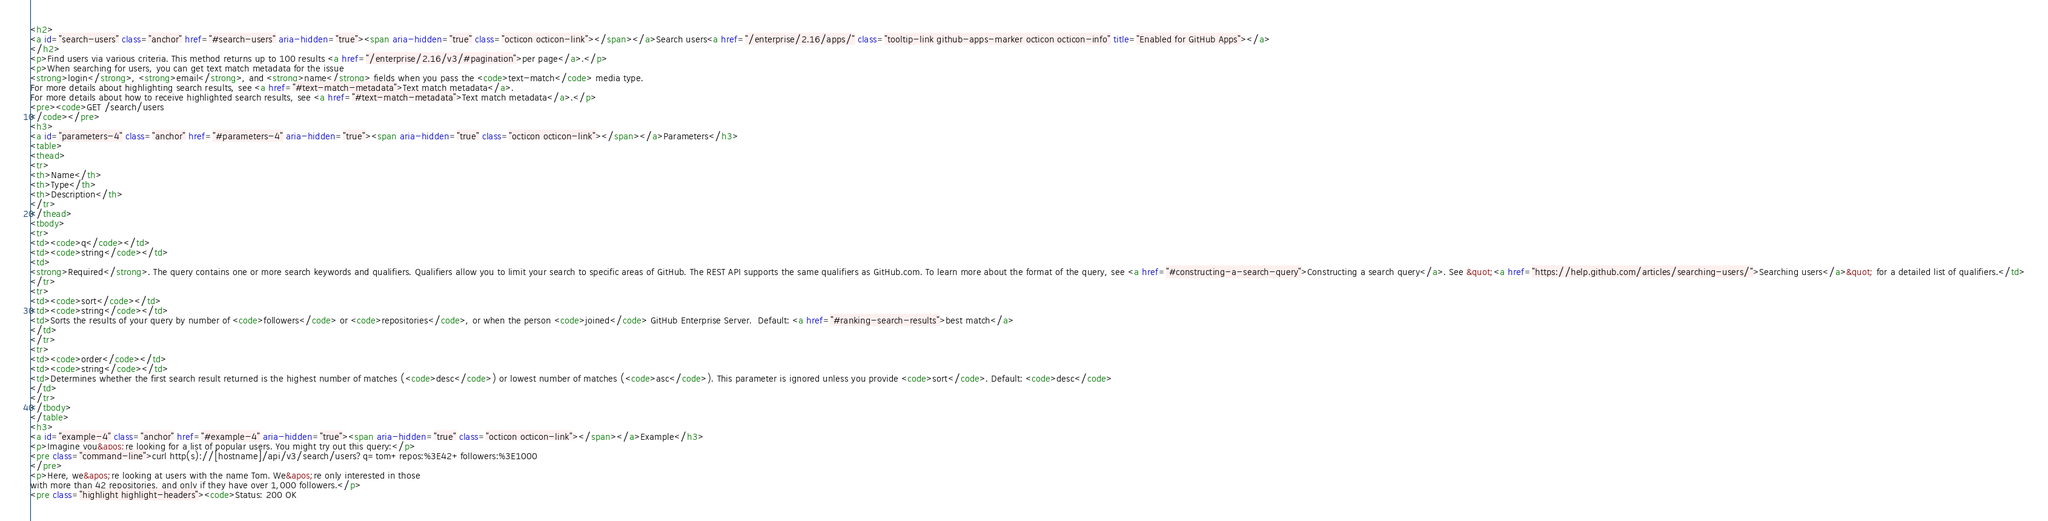Convert code to text. <code><loc_0><loc_0><loc_500><loc_500><_HTML_><h2>
<a id="search-users" class="anchor" href="#search-users" aria-hidden="true"><span aria-hidden="true" class="octicon octicon-link"></span></a>Search users<a href="/enterprise/2.16/apps/" class="tooltip-link github-apps-marker octicon octicon-info" title="Enabled for GitHub Apps"></a>
</h2>
<p>Find users via various criteria. This method returns up to 100 results <a href="/enterprise/2.16/v3/#pagination">per page</a>.</p>
<p>When searching for users, you can get text match metadata for the issue
<strong>login</strong>, <strong>email</strong>, and <strong>name</strong> fields when you pass the <code>text-match</code> media type.
For more details about highlighting search results, see <a href="#text-match-metadata">Text match metadata</a>.
For more details about how to receive highlighted search results, see <a href="#text-match-metadata">Text match metadata</a>.</p>
<pre><code>GET /search/users
</code></pre>
<h3>
<a id="parameters-4" class="anchor" href="#parameters-4" aria-hidden="true"><span aria-hidden="true" class="octicon octicon-link"></span></a>Parameters</h3>
<table>
<thead>
<tr>
<th>Name</th>
<th>Type</th>
<th>Description</th>
</tr>
</thead>
<tbody>
<tr>
<td><code>q</code></td>
<td><code>string</code></td>
<td>
<strong>Required</strong>. The query contains one or more search keywords and qualifiers. Qualifiers allow you to limit your search to specific areas of GitHub. The REST API supports the same qualifiers as GitHub.com. To learn more about the format of the query, see <a href="#constructing-a-search-query">Constructing a search query</a>. See &quot;<a href="https://help.github.com/articles/searching-users/">Searching users</a>&quot; for a detailed list of qualifiers.</td>
</tr>
<tr>
<td><code>sort</code></td>
<td><code>string</code></td>
<td>Sorts the results of your query by number of <code>followers</code> or <code>repositories</code>, or when the person <code>joined</code> GitHub Enterprise Server.  Default: <a href="#ranking-search-results">best match</a>
</td>
</tr>
<tr>
<td><code>order</code></td>
<td><code>string</code></td>
<td>Determines whether the first search result returned is the highest number of matches (<code>desc</code>) or lowest number of matches (<code>asc</code>). This parameter is ignored unless you provide <code>sort</code>. Default: <code>desc</code>
</td>
</tr>
</tbody>
</table>
<h3>
<a id="example-4" class="anchor" href="#example-4" aria-hidden="true"><span aria-hidden="true" class="octicon octicon-link"></span></a>Example</h3>
<p>Imagine you&apos;re looking for a list of popular users. You might try out this query:</p>
<pre class="command-line">curl http(s)://[hostname]/api/v3/search/users?q=tom+repos:%3E42+followers:%3E1000
</pre>
<p>Here, we&apos;re looking at users with the name Tom. We&apos;re only interested in those
with more than 42 repositories, and only if they have over 1,000 followers.</p>
<pre class="highlight highlight-headers"><code>Status: 200 OK</code> 